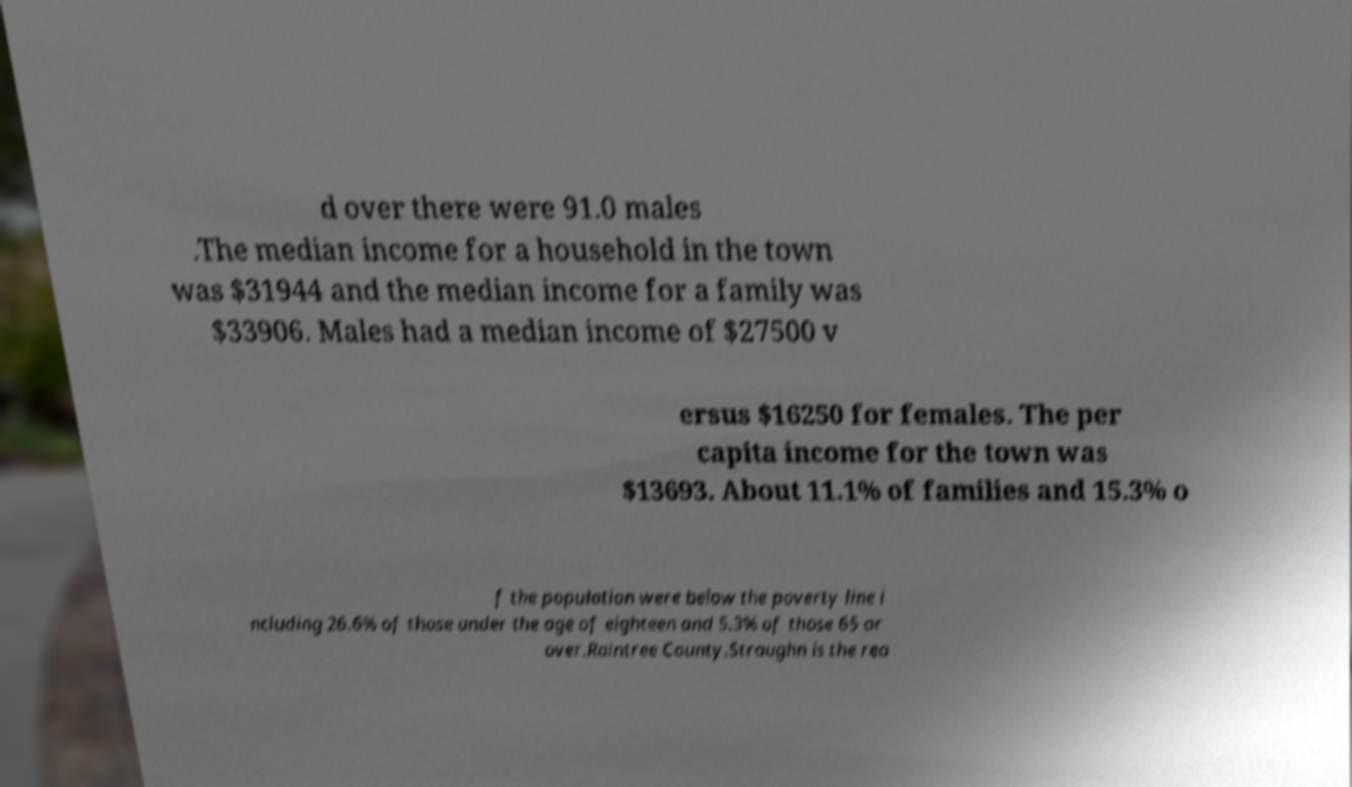What messages or text are displayed in this image? I need them in a readable, typed format. d over there were 91.0 males .The median income for a household in the town was $31944 and the median income for a family was $33906. Males had a median income of $27500 v ersus $16250 for females. The per capita income for the town was $13693. About 11.1% of families and 15.3% o f the population were below the poverty line i ncluding 26.6% of those under the age of eighteen and 5.3% of those 65 or over.Raintree County.Straughn is the rea 